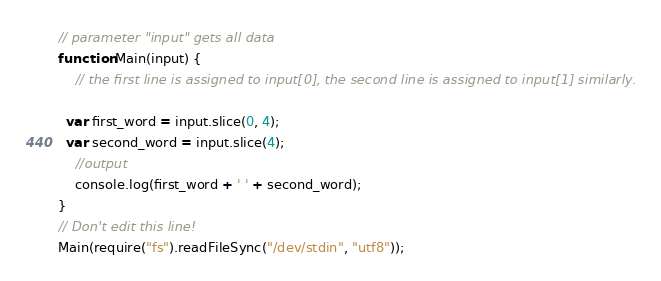<code> <loc_0><loc_0><loc_500><loc_500><_JavaScript_>// parameter "input" gets all data
function Main(input) {
	// the first line is assigned to input[0], the second line is assigned to input[1] similarly.

  var first_word = input.slice(0, 4);
  var second_word = input.slice(4);
	//output
	console.log(first_word + ' ' + second_word);
}
// Don't edit this line!
Main(require("fs").readFileSync("/dev/stdin", "utf8"));</code> 